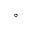Convert formula to latex. <formula><loc_0><loc_0><loc_500><loc_500>^ { \circ }</formula> 